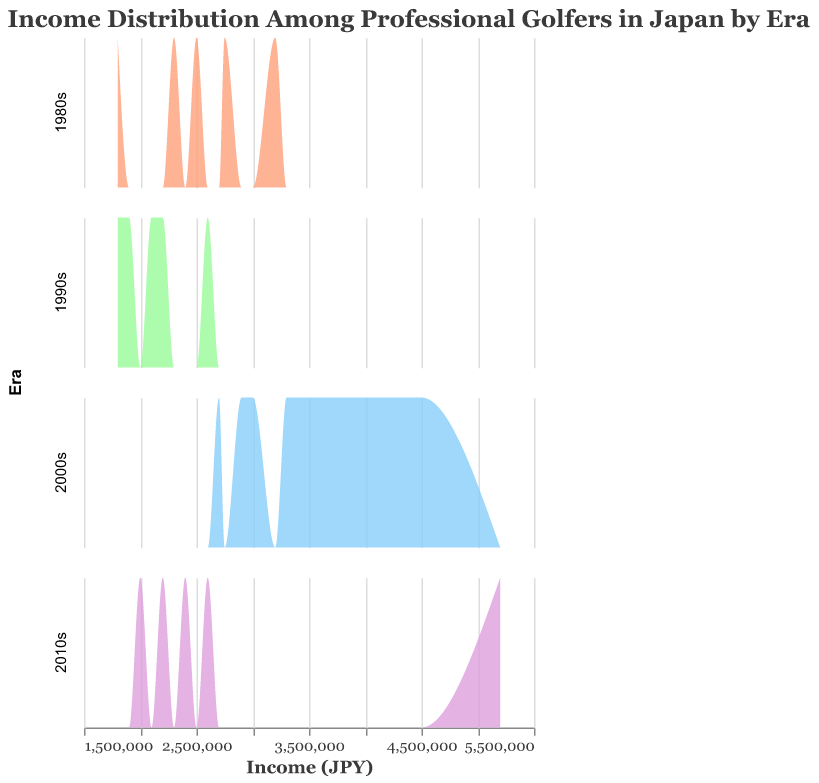What is the title of the figure? The title of the figure is displayed at the top. It reads "Income Distribution Among Professional Golfers in Japan by Era".
Answer: Income Distribution Among Professional Golfers in Japan by Era Which era shows the highest income among the professional golfers? By observing the density plots, we see that the 2010s have the highest income peak with an income of 5,200,000 JPY. This is represented by a noticeable spike on the x-axis under this era.
Answer: 2010s Which era has the widest spread of incomes among golfers? By looking at the width of the density plots on the x-axis for each era, the 2000s era shows the widest spread, ranging from around 2,700,000 JPY to 4,500,000 JPY.
Answer: 2000s How does the income distribution for the 1980s compare to the 1990s? The 1980s and 1990s have overlapping income ranges, but the 1980s have a larger variance with peaks at both lower and higher incomes compared to the 1990s. The 1980s range from about 1,800,000 JPY to 3,200,000 JPY, while the 1990s are more clustered between 1,800,000 JPY and 2,600,000 JPY.
Answer: The 1980s have a wider distribution than the 1990s What is the median income for the 2000s era? Observing the midpoint of the income distribution for the 2000s, we see that it should be approximately halfway along the x-axis of the density plot. The incomes range from about 2,700,000 JPY to 4,500,000 JPY, so the median is approximately at 3,300,000 JPY.
Answer: ~3,300,000 JPY Which era has the least income variability? The era with the least variability in income is the 1990s, as shown by the narrow spread of the density plot on the x-axis, clustered between 1,800,000 JPY and 2,600,000 JPY.
Answer: 1990s Does any era have golfers with an income lower than 2,000,000 JPY? From the density plots, both the 1980s and the 1990s have golfers with incomes lower than 2,000,000 JPY. This is based on the density distributions extending below 2,000,000 JPY on the x-axis.
Answer: Yes, the 1980s and 1990s For which era is the highest income more than double the median income? To determine this, compare the highest income in each era to its median income. For the 2010s, the highest income is 5,200,000 JPY, and the median is around 2,600,000 JPY, which is less than half of the highest income.
Answer: 2010s What trend is visible regarding the highest income from the 1980s to the 2010s? Observing the density plots from the 1980s to the 2010s, there is a clear upward trend in the highest income. Each era sees an increase in the maximum income experienced by golfers.
Answer: An increasing trend 